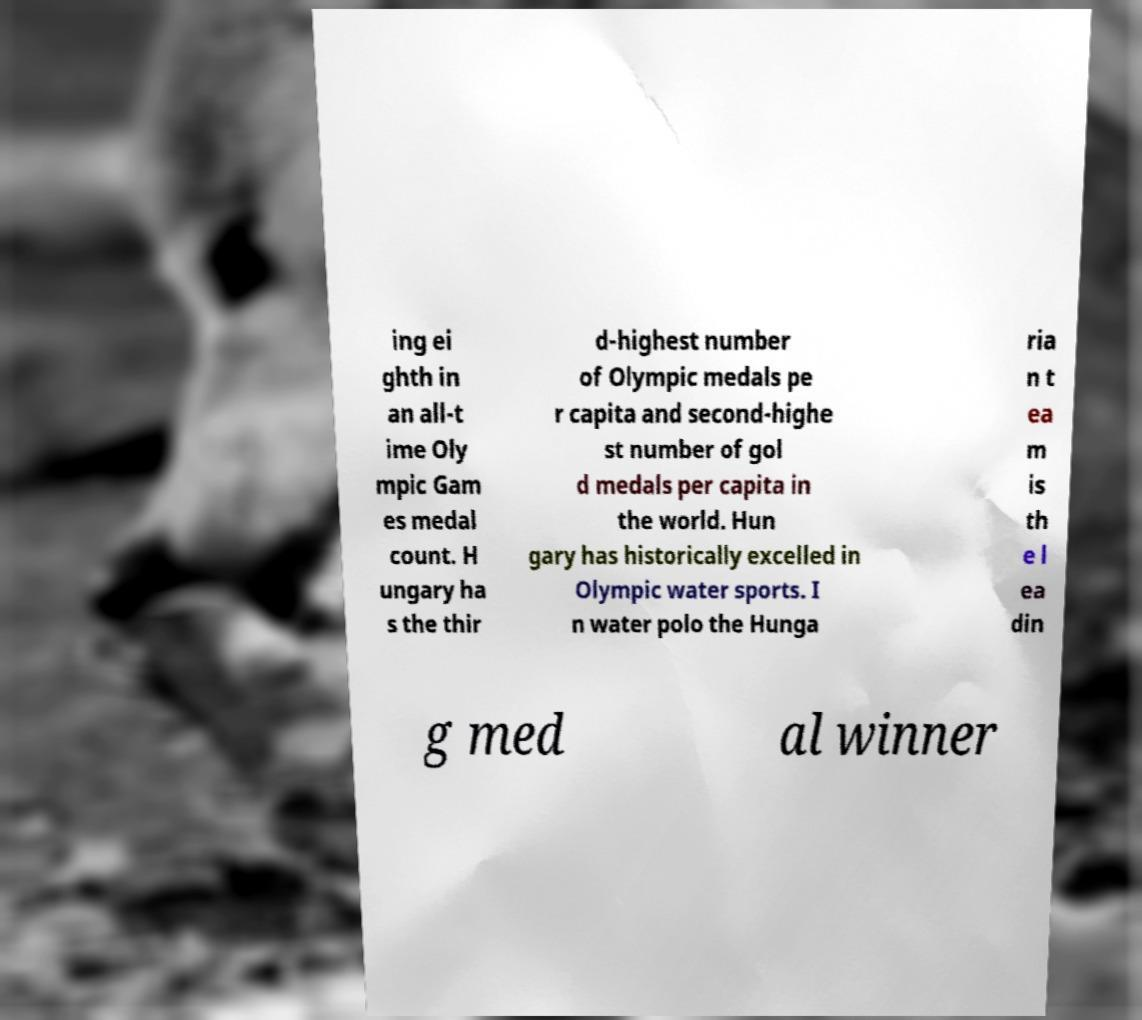Could you assist in decoding the text presented in this image and type it out clearly? ing ei ghth in an all-t ime Oly mpic Gam es medal count. H ungary ha s the thir d-highest number of Olympic medals pe r capita and second-highe st number of gol d medals per capita in the world. Hun gary has historically excelled in Olympic water sports. I n water polo the Hunga ria n t ea m is th e l ea din g med al winner 